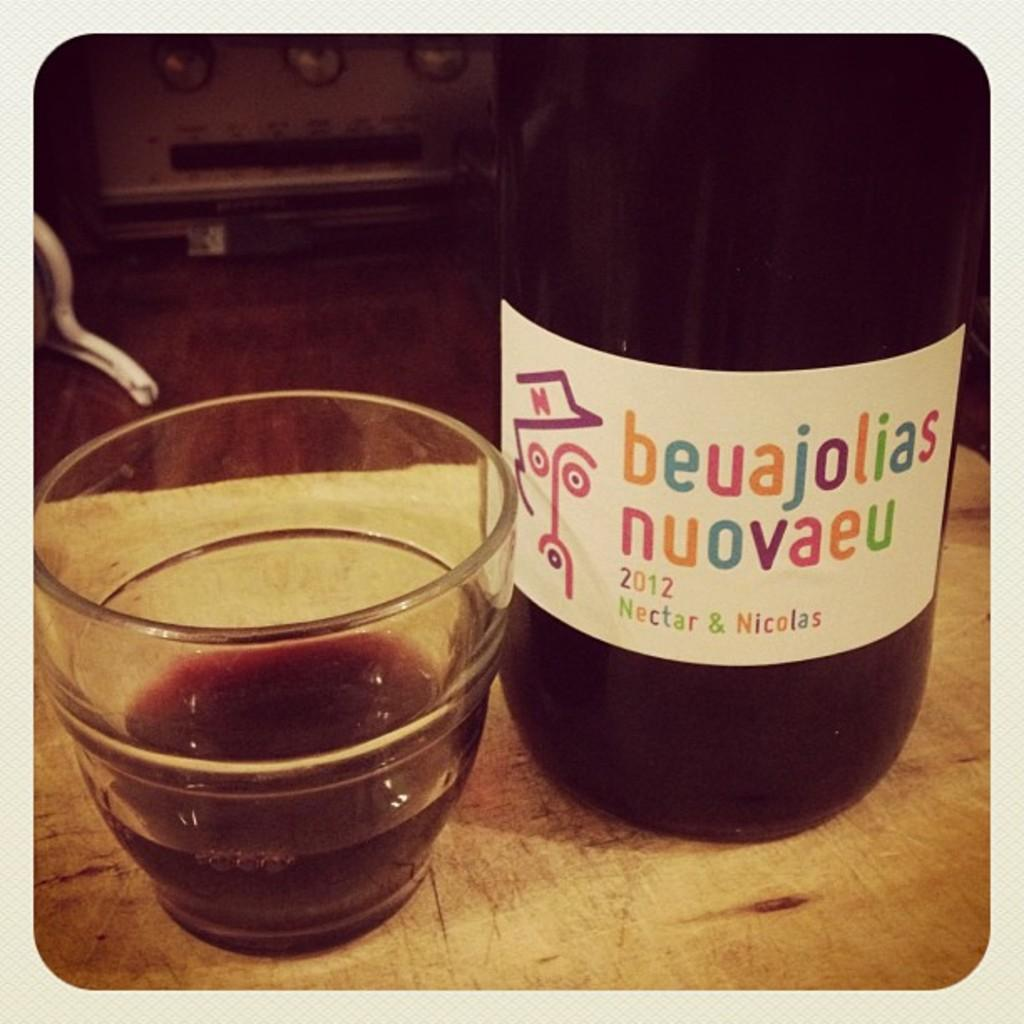<image>
Give a short and clear explanation of the subsequent image. a bottle of beuajolias nuovaeu 2012 nectar & nicolas next to a small glass of it 